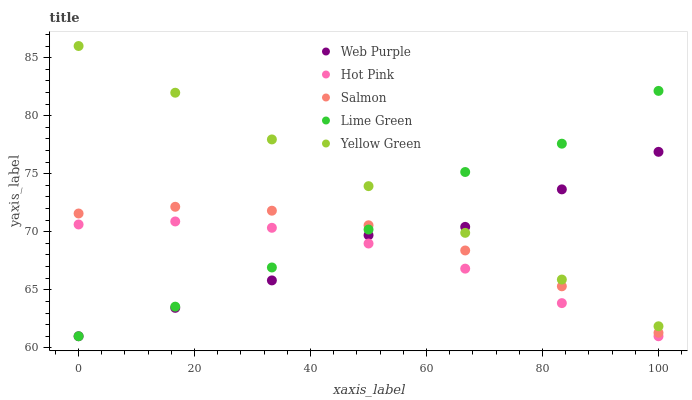Does Hot Pink have the minimum area under the curve?
Answer yes or no. Yes. Does Yellow Green have the maximum area under the curve?
Answer yes or no. Yes. Does Web Purple have the minimum area under the curve?
Answer yes or no. No. Does Web Purple have the maximum area under the curve?
Answer yes or no. No. Is Yellow Green the smoothest?
Answer yes or no. Yes. Is Web Purple the roughest?
Answer yes or no. Yes. Is Hot Pink the smoothest?
Answer yes or no. No. Is Hot Pink the roughest?
Answer yes or no. No. Does Lime Green have the lowest value?
Answer yes or no. Yes. Does Salmon have the lowest value?
Answer yes or no. No. Does Yellow Green have the highest value?
Answer yes or no. Yes. Does Web Purple have the highest value?
Answer yes or no. No. Is Hot Pink less than Yellow Green?
Answer yes or no. Yes. Is Yellow Green greater than Salmon?
Answer yes or no. Yes. Does Web Purple intersect Lime Green?
Answer yes or no. Yes. Is Web Purple less than Lime Green?
Answer yes or no. No. Is Web Purple greater than Lime Green?
Answer yes or no. No. Does Hot Pink intersect Yellow Green?
Answer yes or no. No. 